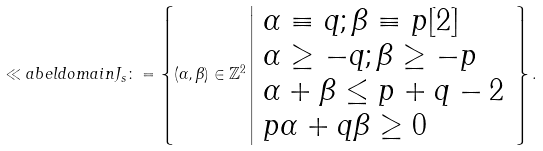Convert formula to latex. <formula><loc_0><loc_0><loc_500><loc_500>\ll a b e l { d o m a i n } J _ { s } \colon = \left \{ ( \alpha , \beta ) \in \mathbb { Z } ^ { 2 } \left | \begin{array} { l } \alpha \equiv q ; \beta \equiv p [ 2 ] \\ \alpha \geq - q ; \beta \geq - p \\ \alpha + \beta \leq p + q - 2 \\ p \alpha + q \beta \geq 0 \end{array} \right . \right \} .</formula> 